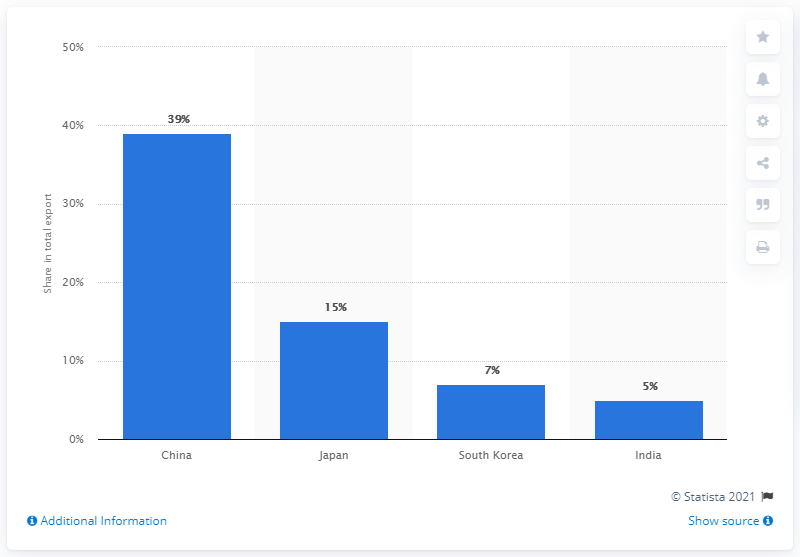Draw attention to some important aspects in this diagram. Australia's main export partner is China. 